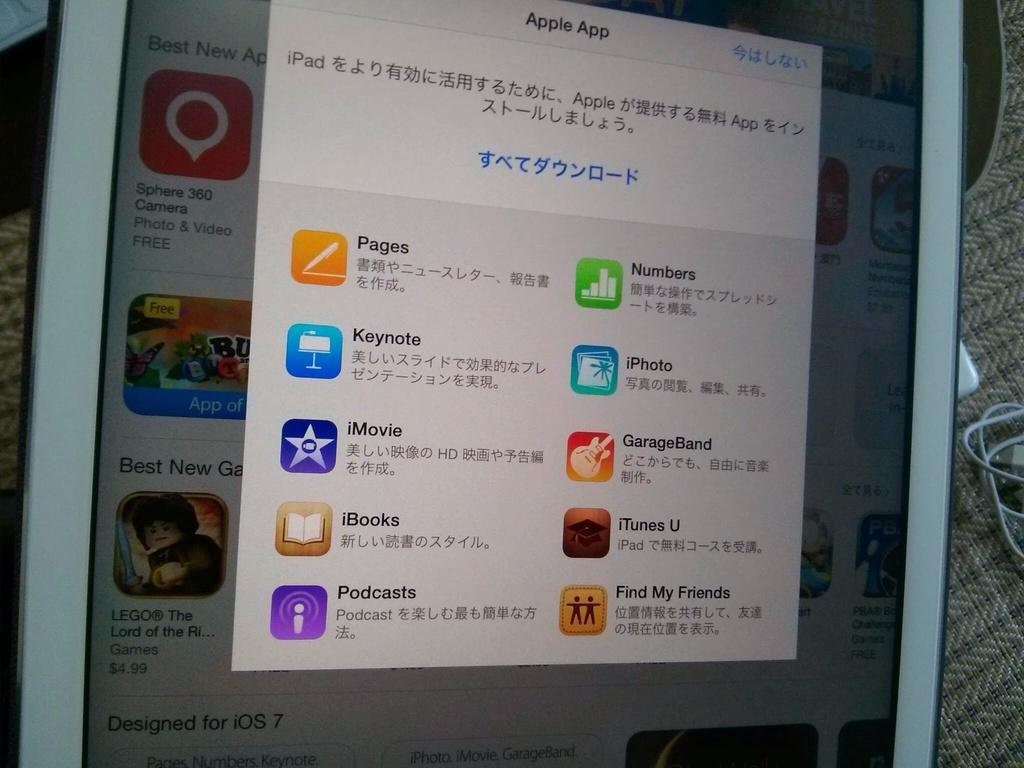What is the main object in the image? There is a screen in the image. What can be seen on the screen? There are applications visible on the screen. What type of collar is visible on the screen? There is no collar present on the screen; it displays applications. 